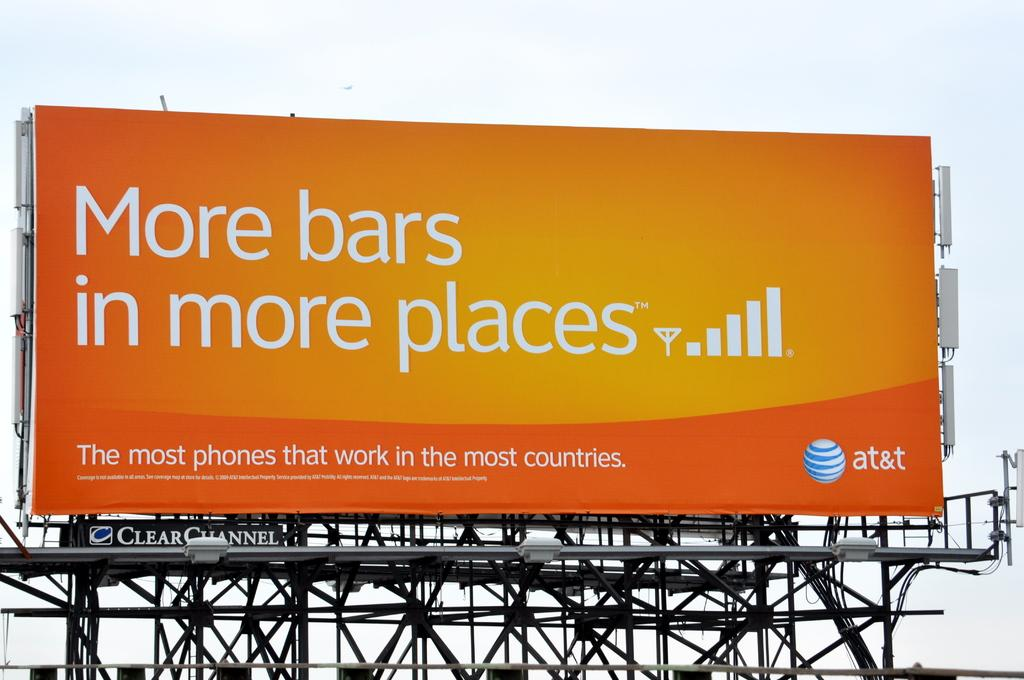<image>
Share a concise interpretation of the image provided. A large AT&T billboard that says More bars in more places. 